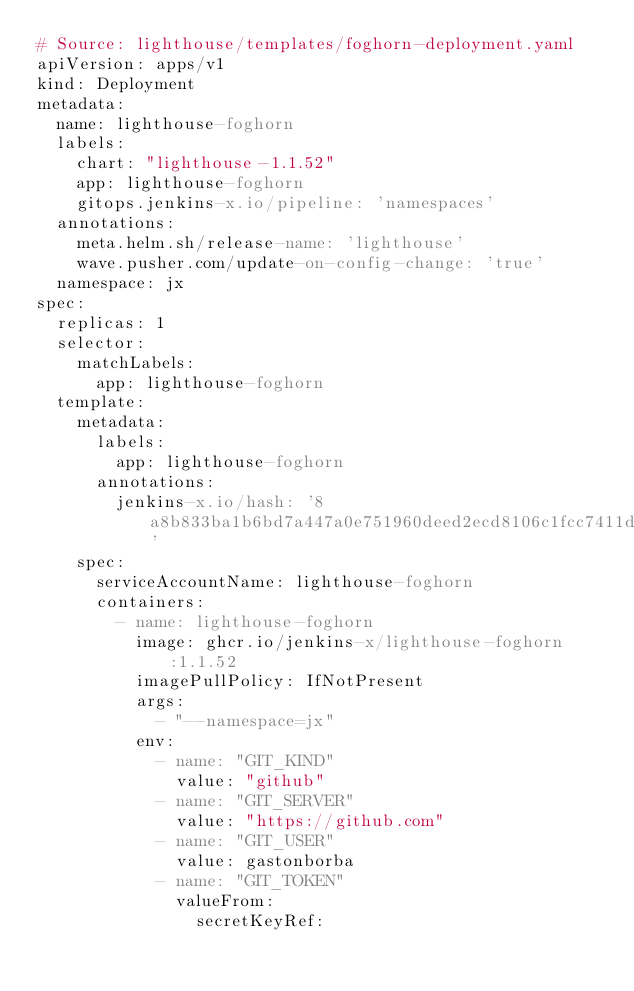<code> <loc_0><loc_0><loc_500><loc_500><_YAML_># Source: lighthouse/templates/foghorn-deployment.yaml
apiVersion: apps/v1
kind: Deployment
metadata:
  name: lighthouse-foghorn
  labels:
    chart: "lighthouse-1.1.52"
    app: lighthouse-foghorn
    gitops.jenkins-x.io/pipeline: 'namespaces'
  annotations:
    meta.helm.sh/release-name: 'lighthouse'
    wave.pusher.com/update-on-config-change: 'true'
  namespace: jx
spec:
  replicas: 1
  selector:
    matchLabels:
      app: lighthouse-foghorn
  template:
    metadata:
      labels:
        app: lighthouse-foghorn
      annotations:
        jenkins-x.io/hash: '8a8b833ba1b6bd7a447a0e751960deed2ecd8106c1fcc7411dada4beae187d06'
    spec:
      serviceAccountName: lighthouse-foghorn
      containers:
        - name: lighthouse-foghorn
          image: ghcr.io/jenkins-x/lighthouse-foghorn:1.1.52
          imagePullPolicy: IfNotPresent
          args:
            - "--namespace=jx"
          env:
            - name: "GIT_KIND"
              value: "github"
            - name: "GIT_SERVER"
              value: "https://github.com"
            - name: "GIT_USER"
              value: gastonborba
            - name: "GIT_TOKEN"
              valueFrom:
                secretKeyRef:</code> 